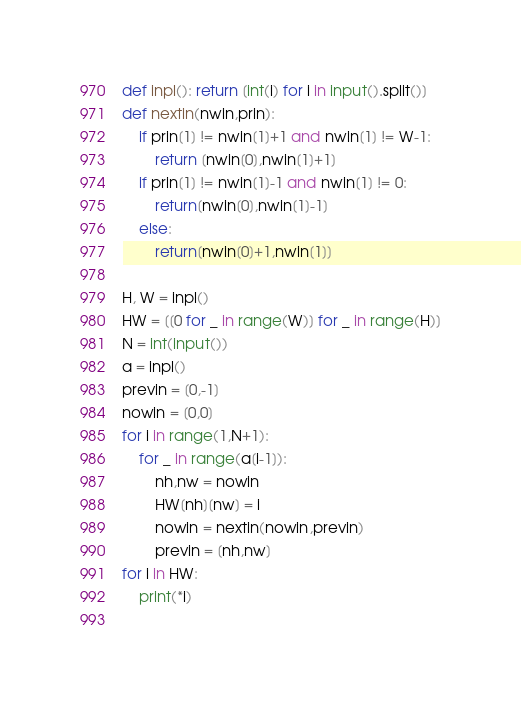Convert code to text. <code><loc_0><loc_0><loc_500><loc_500><_Python_>
def inpl(): return [int(i) for i in input().split()]
def nextin(nwin,prin):
    if prin[1] != nwin[1]+1 and nwin[1] != W-1:
        return [nwin[0],nwin[1]+1]
    if prin[1] != nwin[1]-1 and nwin[1] != 0:
        return[nwin[0],nwin[1]-1]
    else:
        return[nwin[0]+1,nwin[1]]

H, W = inpl()
HW = [[0 for _ in range(W)] for _ in range(H)]
N = int(input())
a = inpl()
previn = [0,-1]
nowin = [0,0]
for i in range(1,N+1):
    for _ in range(a[i-1]):
        nh,nw = nowin
        HW[nh][nw] = i
        nowin = nextin(nowin,previn)
        previn = [nh,nw]
for i in HW:
    print(*i)
        </code> 